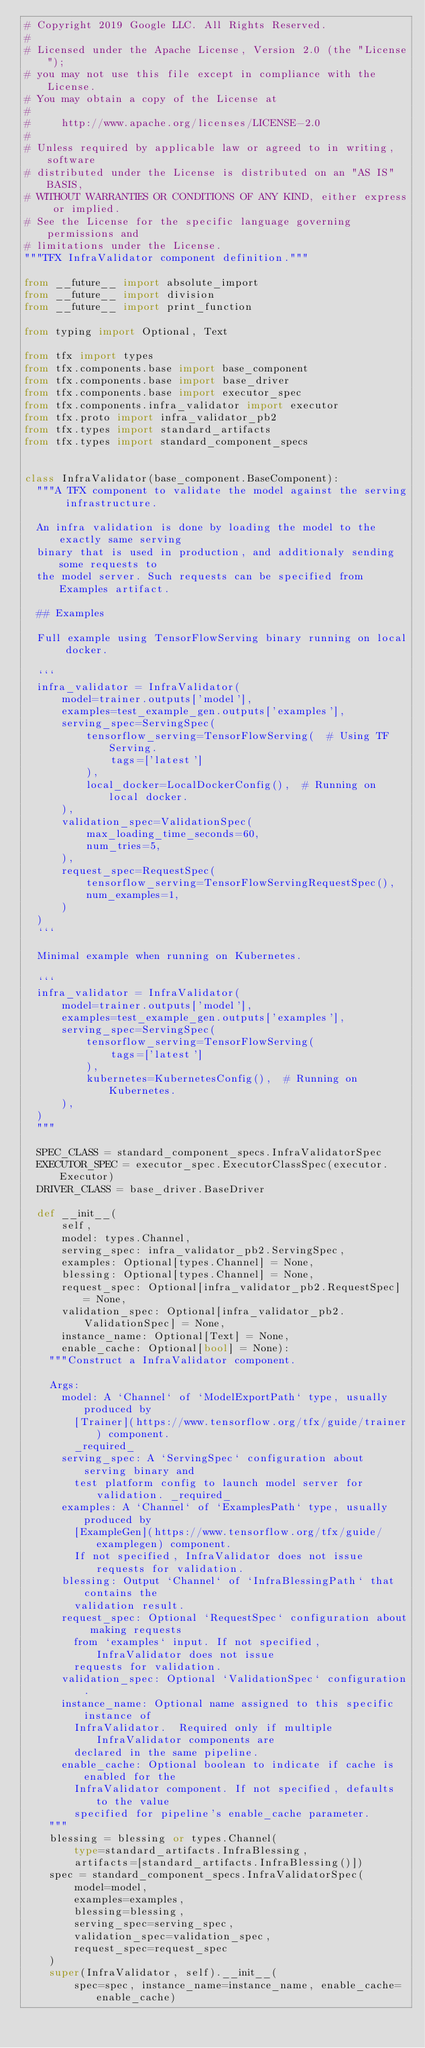Convert code to text. <code><loc_0><loc_0><loc_500><loc_500><_Python_># Copyright 2019 Google LLC. All Rights Reserved.
#
# Licensed under the Apache License, Version 2.0 (the "License");
# you may not use this file except in compliance with the License.
# You may obtain a copy of the License at
#
#     http://www.apache.org/licenses/LICENSE-2.0
#
# Unless required by applicable law or agreed to in writing, software
# distributed under the License is distributed on an "AS IS" BASIS,
# WITHOUT WARRANTIES OR CONDITIONS OF ANY KIND, either express or implied.
# See the License for the specific language governing permissions and
# limitations under the License.
"""TFX InfraValidator component definition."""

from __future__ import absolute_import
from __future__ import division
from __future__ import print_function

from typing import Optional, Text

from tfx import types
from tfx.components.base import base_component
from tfx.components.base import base_driver
from tfx.components.base import executor_spec
from tfx.components.infra_validator import executor
from tfx.proto import infra_validator_pb2
from tfx.types import standard_artifacts
from tfx.types import standard_component_specs


class InfraValidator(base_component.BaseComponent):
  """A TFX component to validate the model against the serving infrastructure.

  An infra validation is done by loading the model to the exactly same serving
  binary that is used in production, and additionaly sending some requests to
  the model server. Such requests can be specified from Examples artifact.

  ## Examples

  Full example using TensorFlowServing binary running on local docker.

  ```
  infra_validator = InfraValidator(
      model=trainer.outputs['model'],
      examples=test_example_gen.outputs['examples'],
      serving_spec=ServingSpec(
          tensorflow_serving=TensorFlowServing(  # Using TF Serving.
              tags=['latest']
          ),
          local_docker=LocalDockerConfig(),  # Running on local docker.
      ),
      validation_spec=ValidationSpec(
          max_loading_time_seconds=60,
          num_tries=5,
      ),
      request_spec=RequestSpec(
          tensorflow_serving=TensorFlowServingRequestSpec(),
          num_examples=1,
      )
  )
  ```

  Minimal example when running on Kubernetes.

  ```
  infra_validator = InfraValidator(
      model=trainer.outputs['model'],
      examples=test_example_gen.outputs['examples'],
      serving_spec=ServingSpec(
          tensorflow_serving=TensorFlowServing(
              tags=['latest']
          ),
          kubernetes=KubernetesConfig(),  # Running on Kubernetes.
      ),
  )
  """

  SPEC_CLASS = standard_component_specs.InfraValidatorSpec
  EXECUTOR_SPEC = executor_spec.ExecutorClassSpec(executor.Executor)
  DRIVER_CLASS = base_driver.BaseDriver

  def __init__(
      self,
      model: types.Channel,
      serving_spec: infra_validator_pb2.ServingSpec,
      examples: Optional[types.Channel] = None,
      blessing: Optional[types.Channel] = None,
      request_spec: Optional[infra_validator_pb2.RequestSpec] = None,
      validation_spec: Optional[infra_validator_pb2.ValidationSpec] = None,
      instance_name: Optional[Text] = None,
      enable_cache: Optional[bool] = None):
    """Construct a InfraValidator component.

    Args:
      model: A `Channel` of `ModelExportPath` type, usually produced by
        [Trainer](https://www.tensorflow.org/tfx/guide/trainer) component.
        _required_
      serving_spec: A `ServingSpec` configuration about serving binary and
        test platform config to launch model server for validation. _required_
      examples: A `Channel` of `ExamplesPath` type, usually produced by
        [ExampleGen](https://www.tensorflow.org/tfx/guide/examplegen) component.
        If not specified, InfraValidator does not issue requests for validation.
      blessing: Output `Channel` of `InfraBlessingPath` that contains the
        validation result.
      request_spec: Optional `RequestSpec` configuration about making requests
        from `examples` input. If not specified, InfraValidator does not issue
        requests for validation.
      validation_spec: Optional `ValidationSpec` configuration.
      instance_name: Optional name assigned to this specific instance of
        InfraValidator.  Required only if multiple InfraValidator components are
        declared in the same pipeline.
      enable_cache: Optional boolean to indicate if cache is enabled for the
        InfraValidator component. If not specified, defaults to the value
        specified for pipeline's enable_cache parameter.
    """
    blessing = blessing or types.Channel(
        type=standard_artifacts.InfraBlessing,
        artifacts=[standard_artifacts.InfraBlessing()])
    spec = standard_component_specs.InfraValidatorSpec(
        model=model,
        examples=examples,
        blessing=blessing,
        serving_spec=serving_spec,
        validation_spec=validation_spec,
        request_spec=request_spec
    )
    super(InfraValidator, self).__init__(
        spec=spec, instance_name=instance_name, enable_cache=enable_cache)
</code> 